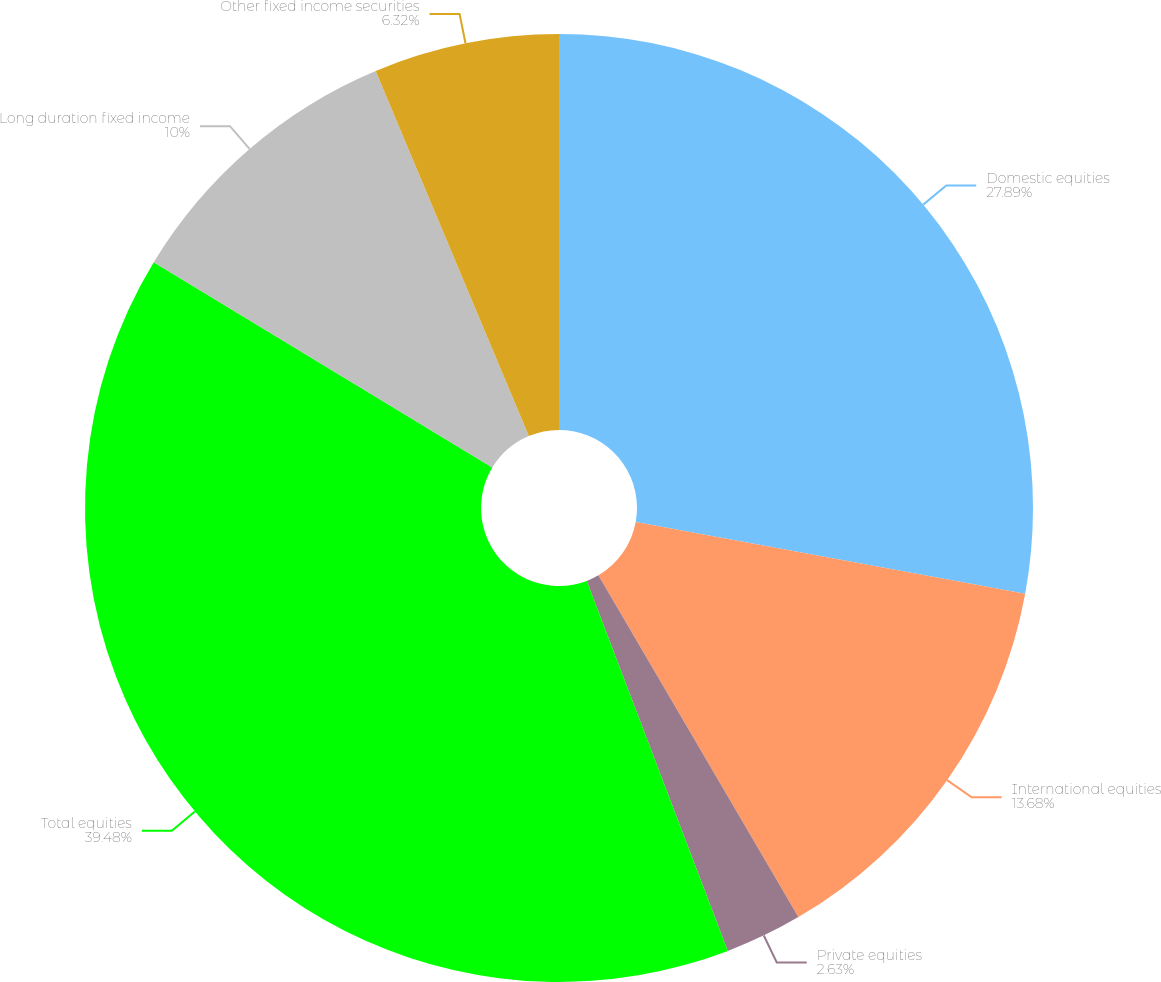Convert chart. <chart><loc_0><loc_0><loc_500><loc_500><pie_chart><fcel>Domestic equities<fcel>International equities<fcel>Private equities<fcel>Total equities<fcel>Long duration fixed income<fcel>Other fixed income securities<nl><fcel>27.89%<fcel>13.68%<fcel>2.63%<fcel>39.47%<fcel>10.0%<fcel>6.32%<nl></chart> 